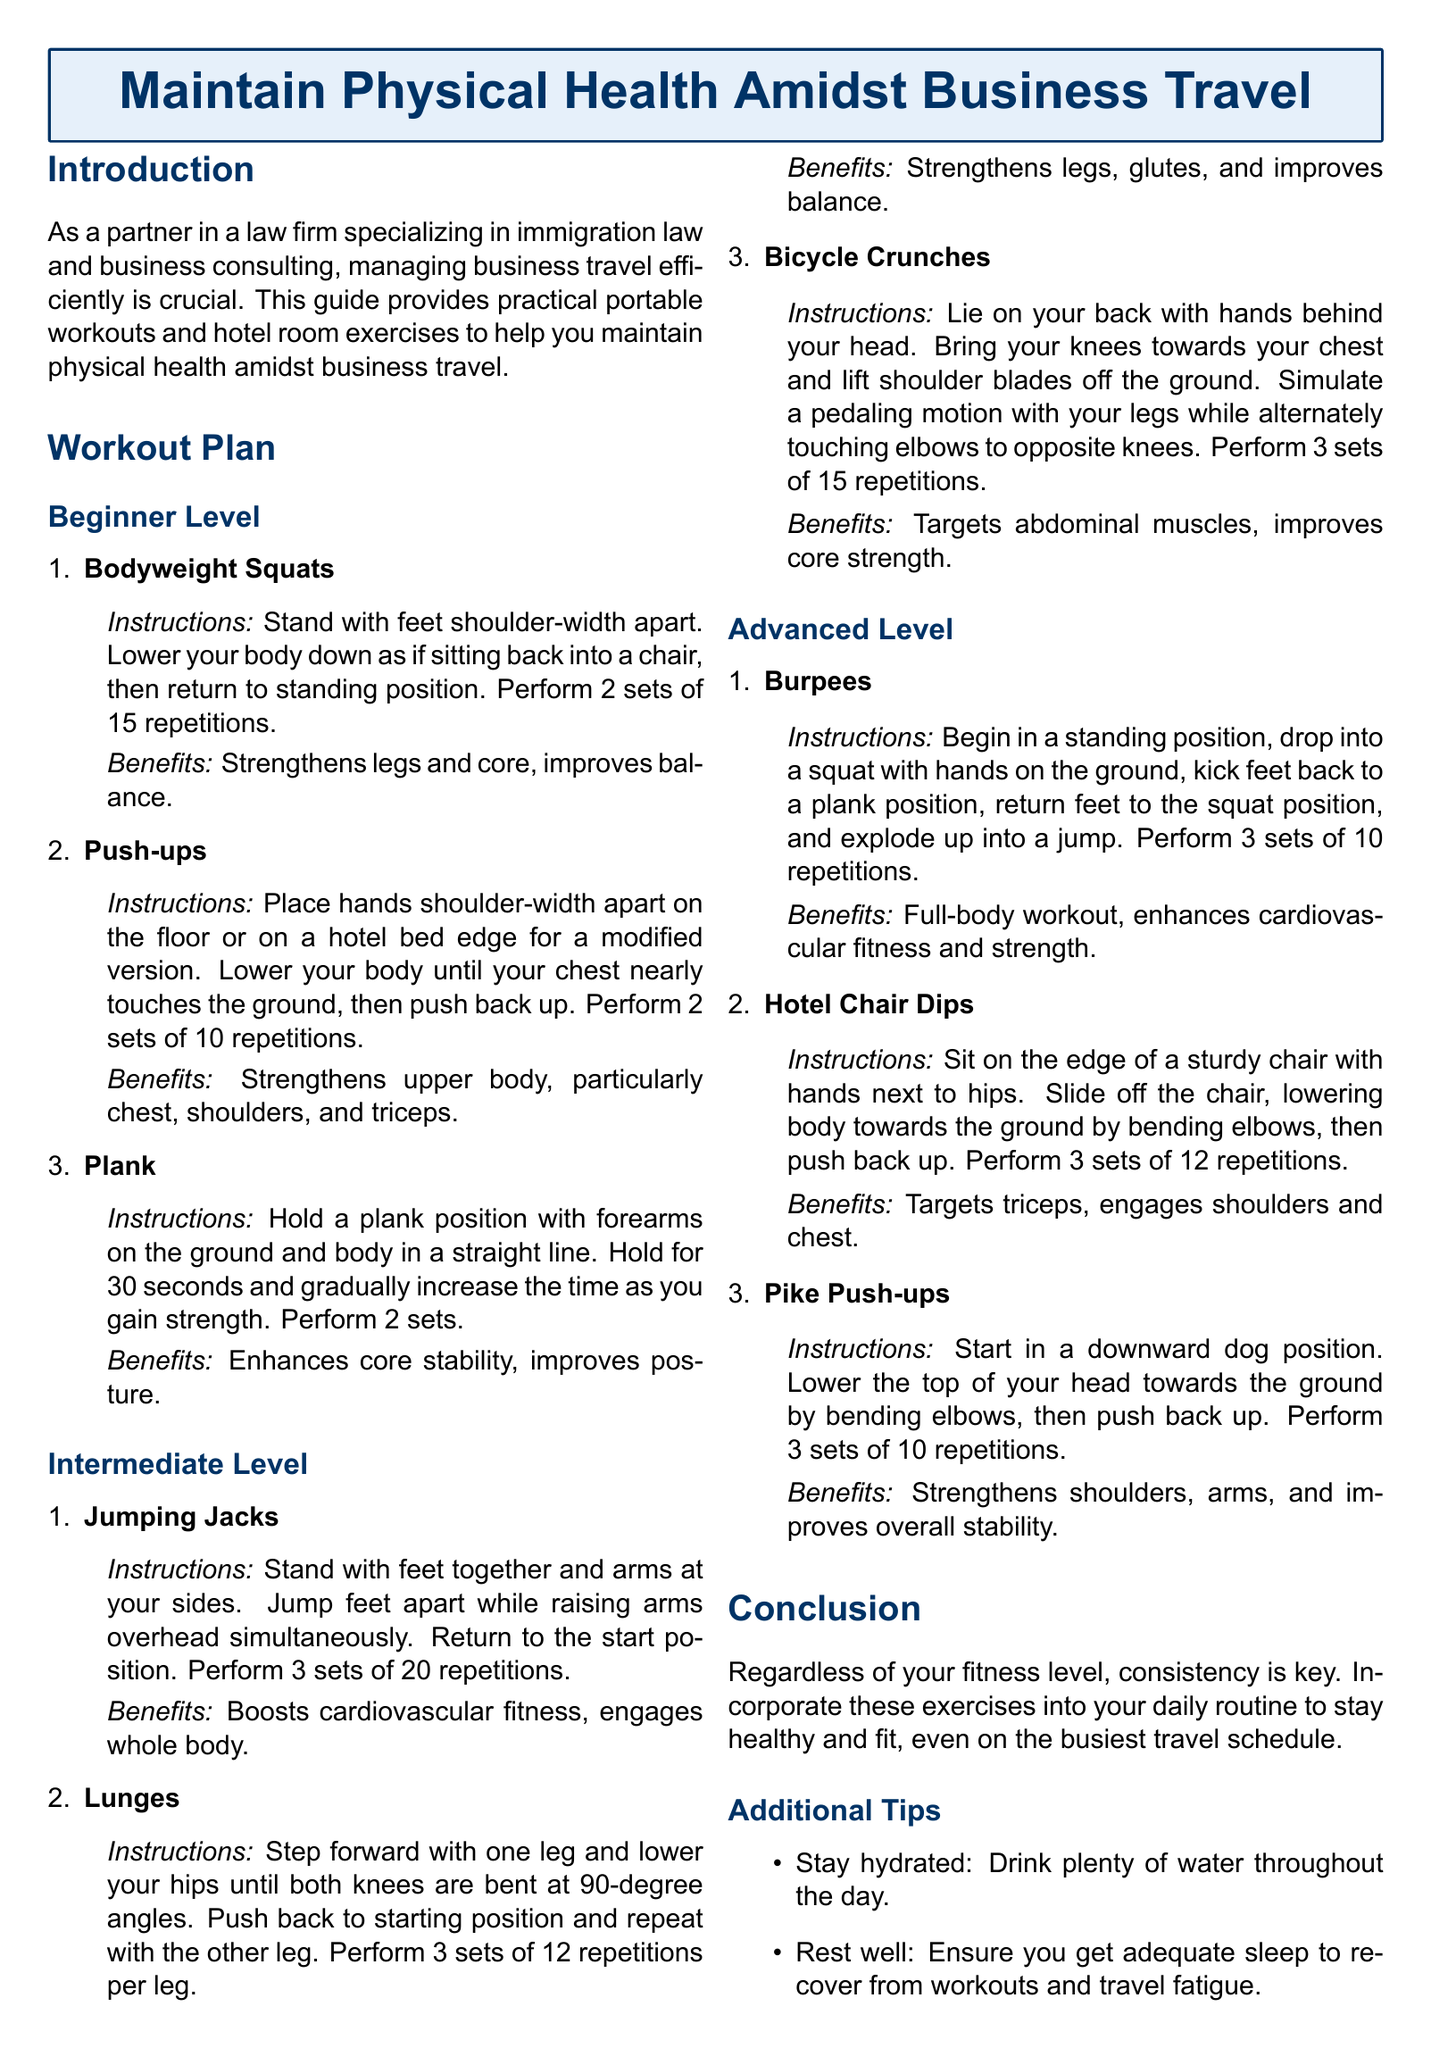what is the title of the document? The title of the document is presented at the beginning in a highlighted box.
Answer: Maintain Physical Health Amidst Business Travel how many sets of bodyweight squats should be performed? The document specifies the number of sets for bodyweight squats as part of the beginner workout.
Answer: 2 sets what is the primary benefit of plank exercises? The document outlines the specific benefits of plank exercises under bodyweight workouts.
Answer: Enhances core stability, improves posture how many repetitions are suggested for bicycle crunches? The document indicates the number of repetitions for bicycle crunches in the intermediate level workout section.
Answer: 15 repetitions what do jumping jacks enhance? The benefits section of the document specifies what jumping jacks improve.
Answer: Boosts cardiovascular fitness, engages whole body how many repetitions are recommended for burpees? The recommended repetitions for burpees are mentioned in the advanced workout section of the document.
Answer: 10 repetitions what type of exercises does the document focus on? The document outlines the types of exercises that can be performed while traveling for business.
Answer: Portable workouts and hotel room exercises what is a key factor in maintaining physical health according to the conclusion? The conclusion highlights an important aspect that contributes to maintaining physical health while traveling.
Answer: Consistency is key what additional tip is provided for maintaining health while traveling? The document provides several additional tips to stay healthy during travel, including hydration advice.
Answer: Stay hydrated what level of difficulty is the pike push-up classified as? The document categorizes the difficulty level of pike push-ups in the workout plan.
Answer: Advanced Level 